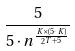<formula> <loc_0><loc_0><loc_500><loc_500>\frac { 5 } { 5 \cdot n ^ { \frac { K \times ( 5 \cdot K ) } { 2 ^ { T + 5 } } } }</formula> 